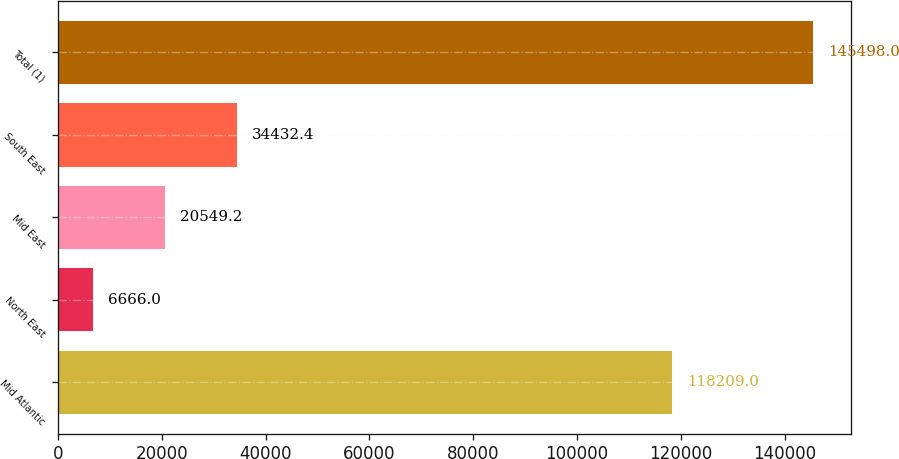Convert chart to OTSL. <chart><loc_0><loc_0><loc_500><loc_500><bar_chart><fcel>Mid Atlantic<fcel>North East<fcel>Mid East<fcel>South East<fcel>Total (1)<nl><fcel>118209<fcel>6666<fcel>20549.2<fcel>34432.4<fcel>145498<nl></chart> 